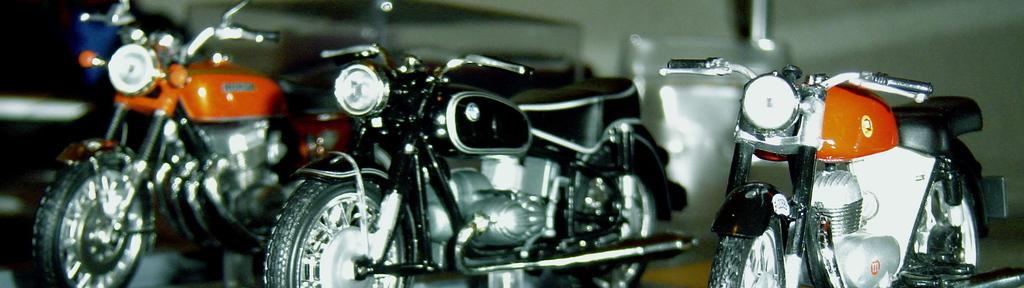What type of vehicles are in the image? There are bikes in the image. How many bikes are in the image? There are three bikes in the image. What colors are the bikes? The bikes are in different colors, including orange and black. Can you describe the positioning of the bikes in the image? There is an orange-colored bike on the left side of the image, an orange-colored bike on the right side of the image, and a black-colored bike in the middle of the image. What is at the bottom of the image? There is a floor at the bottom of the image. How many elbows can be seen on the bikes in the image? There are no elbows visible on the bikes in the image, as bikes do not have elbows. Are there any bears interacting with the bikes in the image? There are no bears present in the image; it features bikes in different colors and positions. 